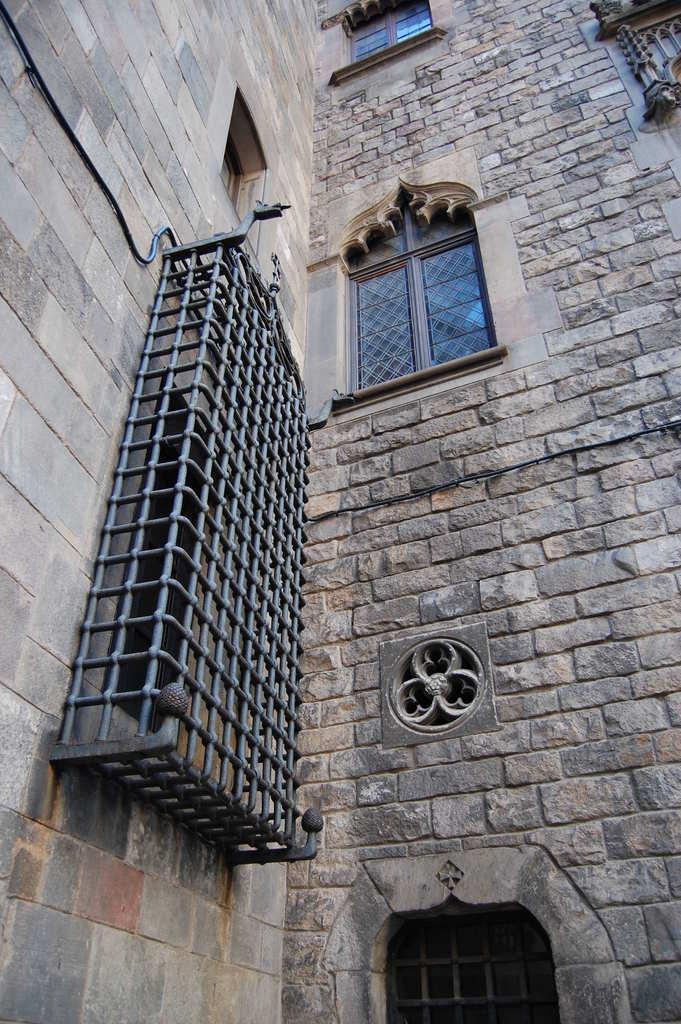Could you give a brief overview of what you see in this image? In this picture we can see a building made of stone walls and there are windows and grill. 